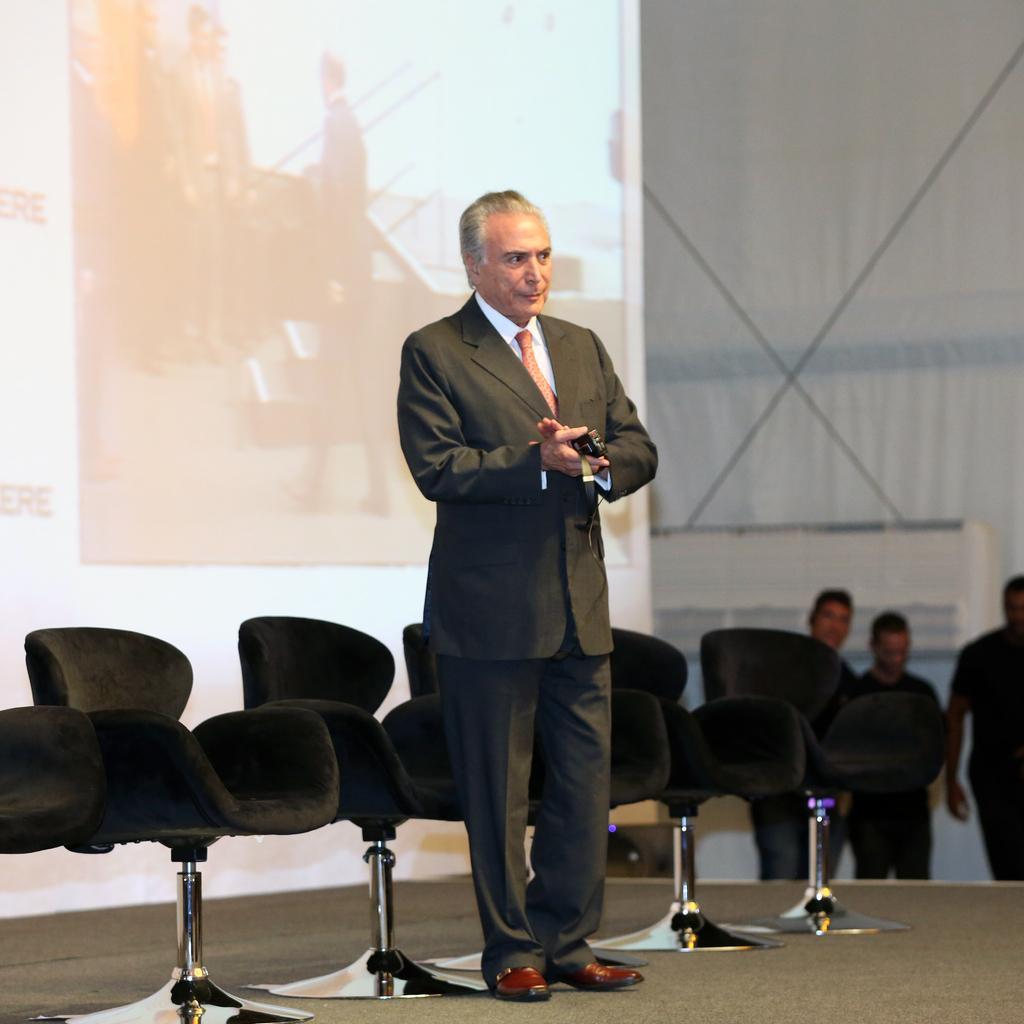Describe this image in one or two sentences. In the middle of the image a man is standing and holding something in his hand. Behind him there are some chairs. Bottom right side of the image few people are standing. Top right side of the image there is wall. Top left side of the image there is a screen. 